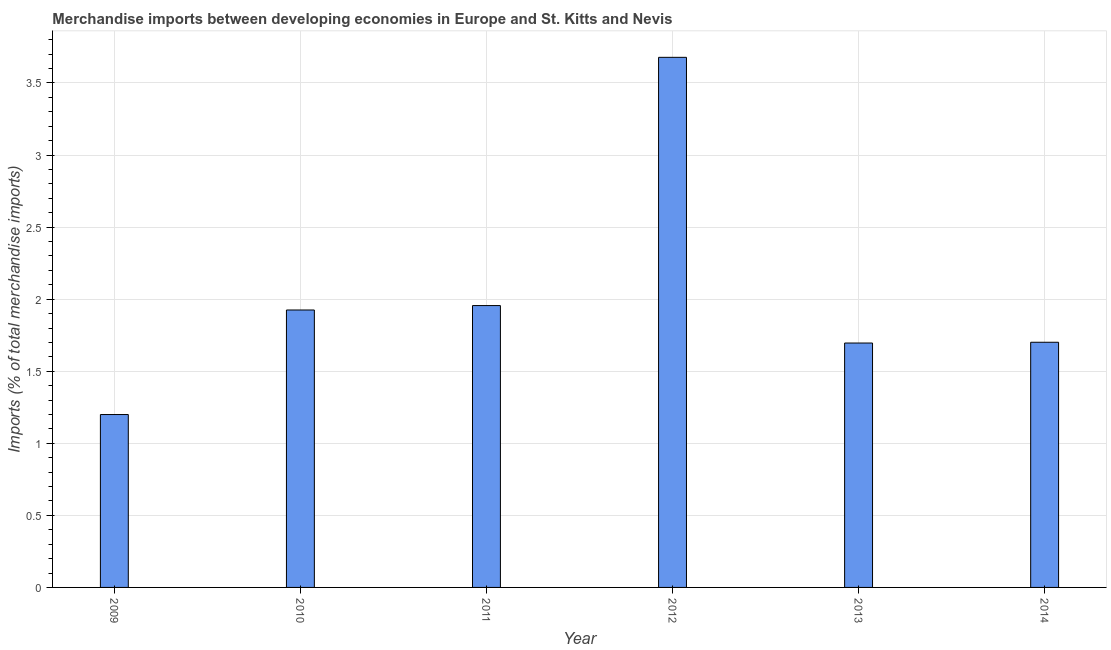Does the graph contain any zero values?
Give a very brief answer. No. Does the graph contain grids?
Offer a very short reply. Yes. What is the title of the graph?
Make the answer very short. Merchandise imports between developing economies in Europe and St. Kitts and Nevis. What is the label or title of the X-axis?
Keep it short and to the point. Year. What is the label or title of the Y-axis?
Your answer should be compact. Imports (% of total merchandise imports). What is the merchandise imports in 2013?
Keep it short and to the point. 1.7. Across all years, what is the maximum merchandise imports?
Your answer should be very brief. 3.68. Across all years, what is the minimum merchandise imports?
Offer a very short reply. 1.2. In which year was the merchandise imports maximum?
Make the answer very short. 2012. In which year was the merchandise imports minimum?
Your answer should be compact. 2009. What is the sum of the merchandise imports?
Offer a terse response. 12.16. What is the difference between the merchandise imports in 2011 and 2012?
Offer a very short reply. -1.72. What is the average merchandise imports per year?
Provide a succinct answer. 2.03. What is the median merchandise imports?
Provide a succinct answer. 1.81. Do a majority of the years between 2009 and 2010 (inclusive) have merchandise imports greater than 0.4 %?
Give a very brief answer. Yes. What is the ratio of the merchandise imports in 2011 to that in 2014?
Your answer should be very brief. 1.15. Is the merchandise imports in 2013 less than that in 2014?
Your answer should be very brief. Yes. Is the difference between the merchandise imports in 2010 and 2011 greater than the difference between any two years?
Offer a very short reply. No. What is the difference between the highest and the second highest merchandise imports?
Your response must be concise. 1.72. Is the sum of the merchandise imports in 2009 and 2011 greater than the maximum merchandise imports across all years?
Provide a succinct answer. No. What is the difference between the highest and the lowest merchandise imports?
Your answer should be very brief. 2.48. In how many years, is the merchandise imports greater than the average merchandise imports taken over all years?
Provide a short and direct response. 1. Are all the bars in the graph horizontal?
Ensure brevity in your answer.  No. What is the difference between two consecutive major ticks on the Y-axis?
Your response must be concise. 0.5. What is the Imports (% of total merchandise imports) in 2009?
Your response must be concise. 1.2. What is the Imports (% of total merchandise imports) of 2010?
Your response must be concise. 1.93. What is the Imports (% of total merchandise imports) in 2011?
Ensure brevity in your answer.  1.96. What is the Imports (% of total merchandise imports) of 2012?
Your answer should be compact. 3.68. What is the Imports (% of total merchandise imports) in 2013?
Make the answer very short. 1.7. What is the Imports (% of total merchandise imports) of 2014?
Provide a succinct answer. 1.7. What is the difference between the Imports (% of total merchandise imports) in 2009 and 2010?
Your answer should be very brief. -0.73. What is the difference between the Imports (% of total merchandise imports) in 2009 and 2011?
Provide a short and direct response. -0.76. What is the difference between the Imports (% of total merchandise imports) in 2009 and 2012?
Offer a very short reply. -2.48. What is the difference between the Imports (% of total merchandise imports) in 2009 and 2013?
Your answer should be compact. -0.5. What is the difference between the Imports (% of total merchandise imports) in 2009 and 2014?
Your answer should be compact. -0.5. What is the difference between the Imports (% of total merchandise imports) in 2010 and 2011?
Your answer should be very brief. -0.03. What is the difference between the Imports (% of total merchandise imports) in 2010 and 2012?
Your response must be concise. -1.75. What is the difference between the Imports (% of total merchandise imports) in 2010 and 2013?
Give a very brief answer. 0.23. What is the difference between the Imports (% of total merchandise imports) in 2010 and 2014?
Your response must be concise. 0.22. What is the difference between the Imports (% of total merchandise imports) in 2011 and 2012?
Give a very brief answer. -1.72. What is the difference between the Imports (% of total merchandise imports) in 2011 and 2013?
Your response must be concise. 0.26. What is the difference between the Imports (% of total merchandise imports) in 2011 and 2014?
Provide a succinct answer. 0.25. What is the difference between the Imports (% of total merchandise imports) in 2012 and 2013?
Your response must be concise. 1.98. What is the difference between the Imports (% of total merchandise imports) in 2012 and 2014?
Give a very brief answer. 1.98. What is the difference between the Imports (% of total merchandise imports) in 2013 and 2014?
Keep it short and to the point. -0.01. What is the ratio of the Imports (% of total merchandise imports) in 2009 to that in 2010?
Your answer should be very brief. 0.62. What is the ratio of the Imports (% of total merchandise imports) in 2009 to that in 2011?
Your answer should be compact. 0.61. What is the ratio of the Imports (% of total merchandise imports) in 2009 to that in 2012?
Your answer should be compact. 0.33. What is the ratio of the Imports (% of total merchandise imports) in 2009 to that in 2013?
Your answer should be very brief. 0.71. What is the ratio of the Imports (% of total merchandise imports) in 2009 to that in 2014?
Make the answer very short. 0.7. What is the ratio of the Imports (% of total merchandise imports) in 2010 to that in 2011?
Offer a terse response. 0.98. What is the ratio of the Imports (% of total merchandise imports) in 2010 to that in 2012?
Ensure brevity in your answer.  0.52. What is the ratio of the Imports (% of total merchandise imports) in 2010 to that in 2013?
Offer a terse response. 1.14. What is the ratio of the Imports (% of total merchandise imports) in 2010 to that in 2014?
Offer a terse response. 1.13. What is the ratio of the Imports (% of total merchandise imports) in 2011 to that in 2012?
Keep it short and to the point. 0.53. What is the ratio of the Imports (% of total merchandise imports) in 2011 to that in 2013?
Ensure brevity in your answer.  1.15. What is the ratio of the Imports (% of total merchandise imports) in 2011 to that in 2014?
Give a very brief answer. 1.15. What is the ratio of the Imports (% of total merchandise imports) in 2012 to that in 2013?
Your response must be concise. 2.17. What is the ratio of the Imports (% of total merchandise imports) in 2012 to that in 2014?
Make the answer very short. 2.16. 